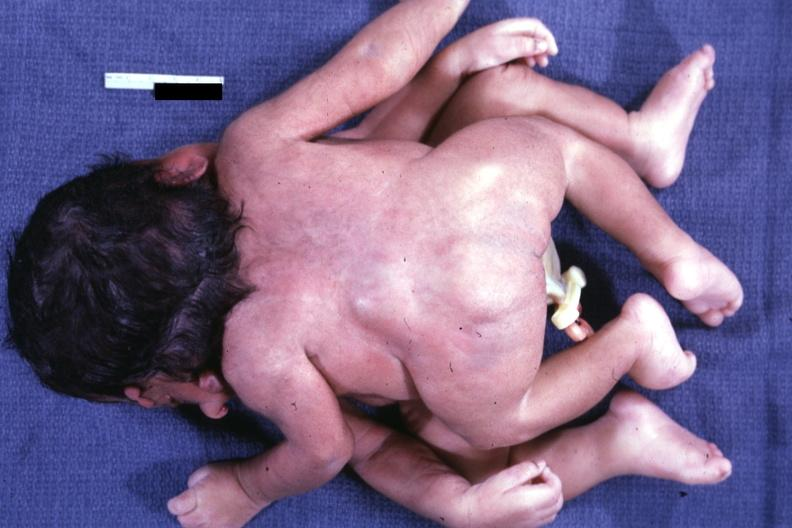how is twins joined at head facing each?
Answer the question using a single word or phrase. Other 